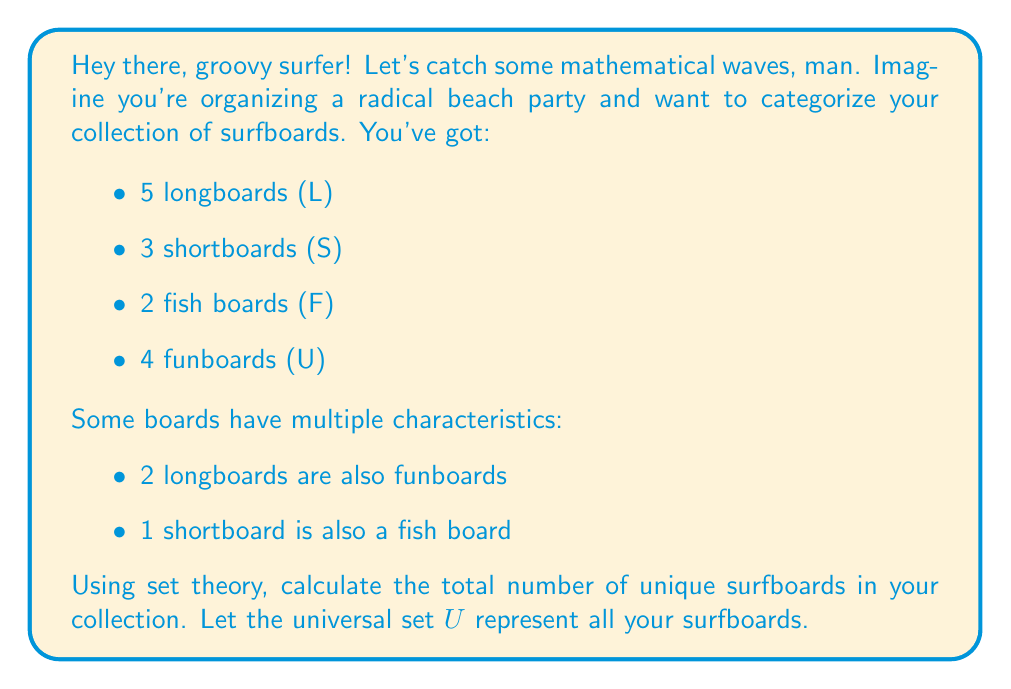Can you answer this question? Alright, dude, let's break this down step-by-step:

1) First, let's define our sets:
   $L$ = set of longboards
   $S$ = set of shortboards
   $F$ = set of fish boards
   $U$ = set of funboards

2) We're given these cardinalities:
   $|L| = 5$
   $|S| = 3$
   $|F| = 2$
   $|U| = 4$

3) We're also told about some overlaps:
   $|L \cap U| = 2$ (2 longboards are also funboards)
   $|S \cap F| = 1$ (1 shortboard is also a fish board)

4) To find the total number of unique surfboards, we need to use the principle of inclusion-exclusion. The formula for four sets is:

   $$|A \cup B \cup C \cup D| = |A| + |B| + |C| + |D| - |A \cap B| - |A \cap C| - |A \cap D| - |B \cap C| - |B \cap D| - |C \cap D| + |A \cap B \cap C| + |A \cap B \cap D| + |A \cap C \cap D| + |B \cap C \cap D| - |A \cap B \cap C \cap D|$$

5) In our case, we only know about two intersections, and we can assume all other intersections are empty. So our equation simplifies to:

   $$|L \cup S \cup F \cup U| = |L| + |S| + |F| + |U| - |L \cap U| - |S \cap F|$$

6) Now, let's plug in our numbers:

   $$|L \cup S \cup F \cup U| = 5 + 3 + 2 + 4 - 2 - 1 = 11$$

So, the total number of unique surfboards in your collection is 11.
Answer: 11 unique surfboards 